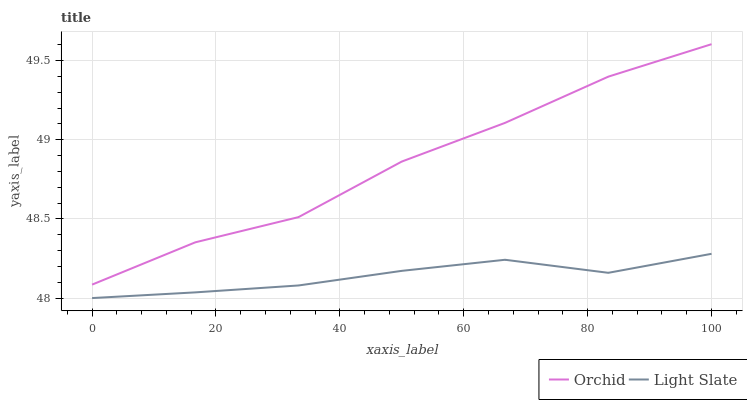Does Light Slate have the minimum area under the curve?
Answer yes or no. Yes. Does Orchid have the maximum area under the curve?
Answer yes or no. Yes. Does Orchid have the minimum area under the curve?
Answer yes or no. No. Is Light Slate the smoothest?
Answer yes or no. Yes. Is Orchid the roughest?
Answer yes or no. Yes. Is Orchid the smoothest?
Answer yes or no. No. Does Orchid have the lowest value?
Answer yes or no. No. Does Orchid have the highest value?
Answer yes or no. Yes. Is Light Slate less than Orchid?
Answer yes or no. Yes. Is Orchid greater than Light Slate?
Answer yes or no. Yes. Does Light Slate intersect Orchid?
Answer yes or no. No. 